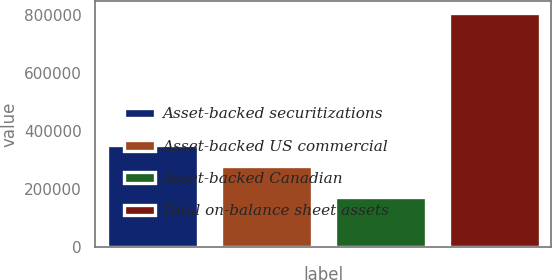<chart> <loc_0><loc_0><loc_500><loc_500><bar_chart><fcel>Asset-backed securitizations<fcel>Asset-backed US commercial<fcel>Asset-backed Canadian<fcel>Total on-balance sheet assets<nl><fcel>352624<fcel>279457<fcel>174779<fcel>806860<nl></chart> 